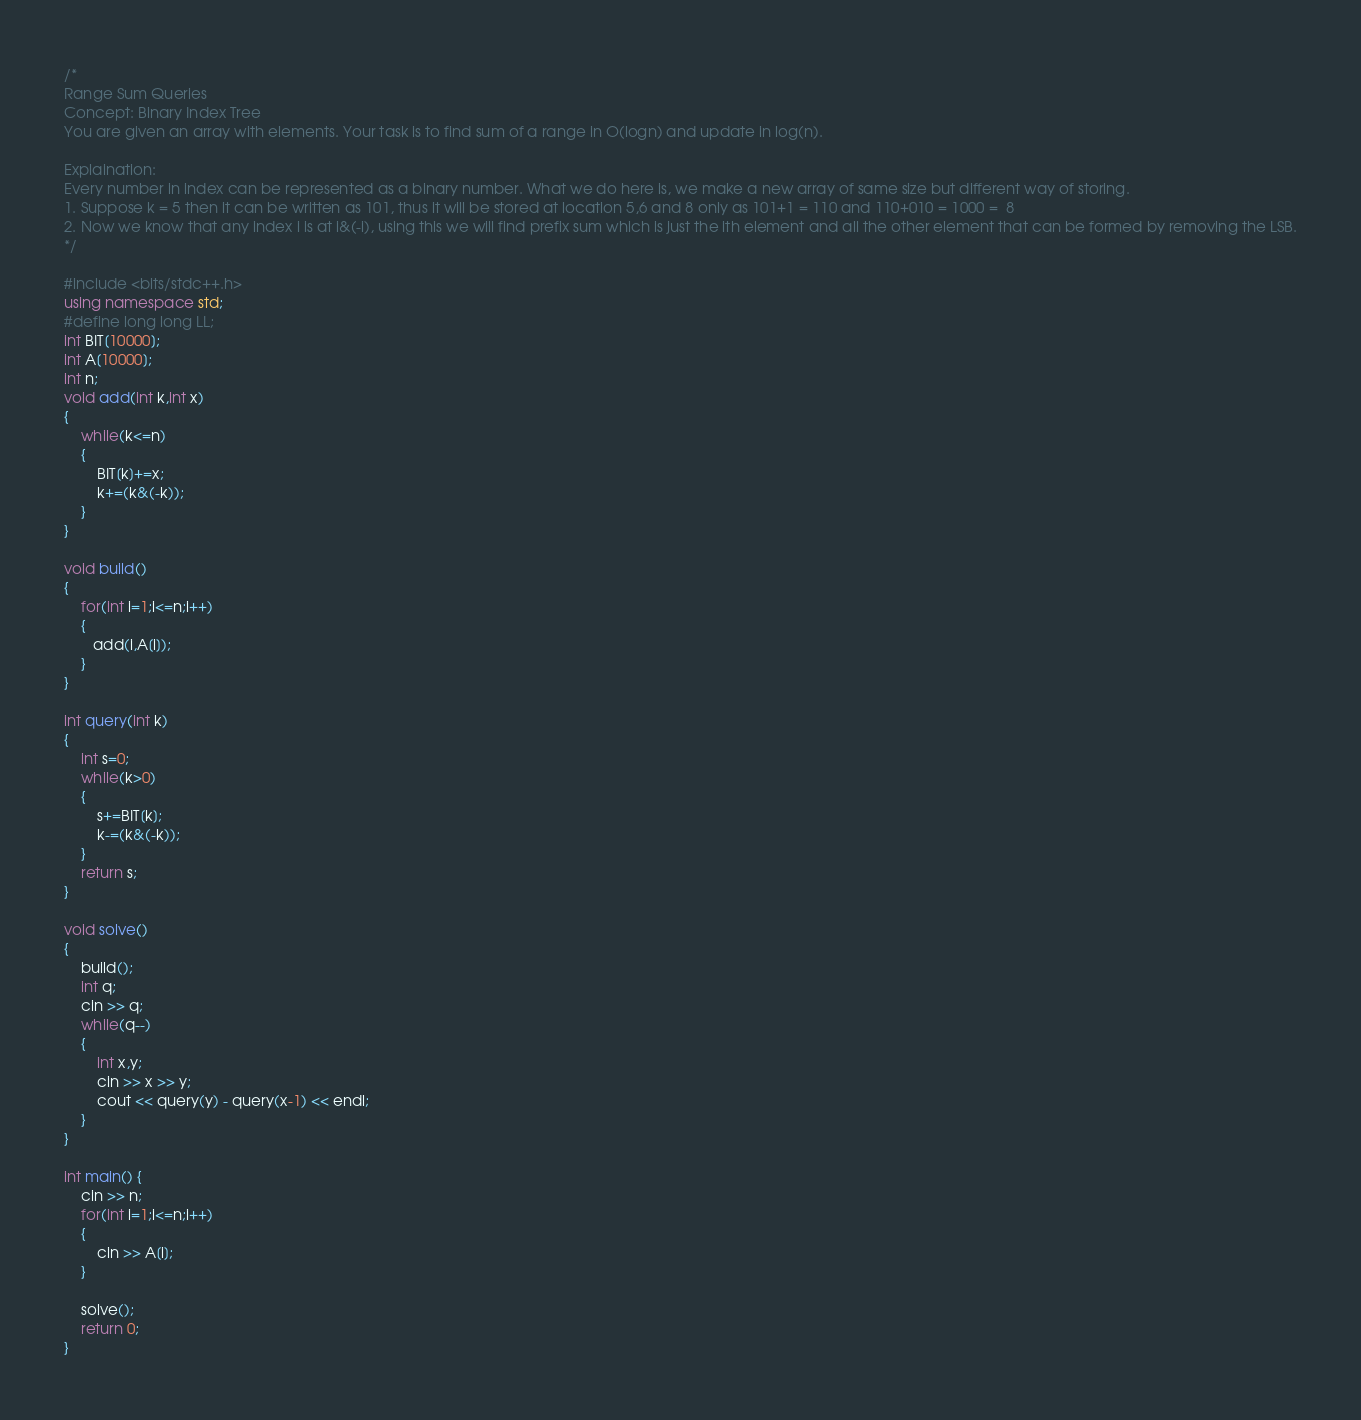<code> <loc_0><loc_0><loc_500><loc_500><_C++_>/* 
Range Sum Queries
Concept: Binary Index Tree
You are given an array with elements. Your task is to find sum of a range in O(logn) and update in log(n).

Explaination:
Every number in index can be represented as a binary number. What we do here is, we make a new array of same size but different way of storing. 
1. Suppose k = 5 then it can be written as 101, thus it will be stored at location 5,6 and 8 only as 101+1 = 110 and 110+010 = 1000 =  8
2. Now we know that any index i is at i&(-i), using this we will find prefix sum which is just the ith element and all the other element that can be formed by removing the LSB.
*/

#include <bits/stdc++.h>
using namespace std;
#define long long LL;
int BIT[10000];
int A[10000];
int n;
void add(int k,int x)
{
    while(k<=n)
    {
        BIT[k]+=x;
        k+=(k&(-k));
    }
}

void build()
{
    for(int i=1;i<=n;i++)
    {
       add(i,A[i]);
    }
}

int query(int k)
{
    int s=0;
    while(k>0)
    {
        s+=BIT[k];
        k-=(k&(-k));
    }
    return s;
}

void solve()
{
    build();
    int q;
    cin >> q;
    while(q--)
    {
        int x,y;
        cin >> x >> y;
        cout << query(y) - query(x-1) << endl;
    }
}

int main() {
    cin >> n;
    for(int i=1;i<=n;i++)
    {
        cin >> A[i];
    }

    solve();
    return 0;
}

</code> 